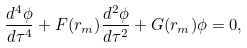Convert formula to latex. <formula><loc_0><loc_0><loc_500><loc_500>\frac { d ^ { 4 } \phi } { d \tau ^ { 4 } } + F ( r _ { m } ) \frac { d ^ { 2 } \phi } { d \tau ^ { 2 } } + G ( r _ { m } ) \phi = 0 ,</formula> 